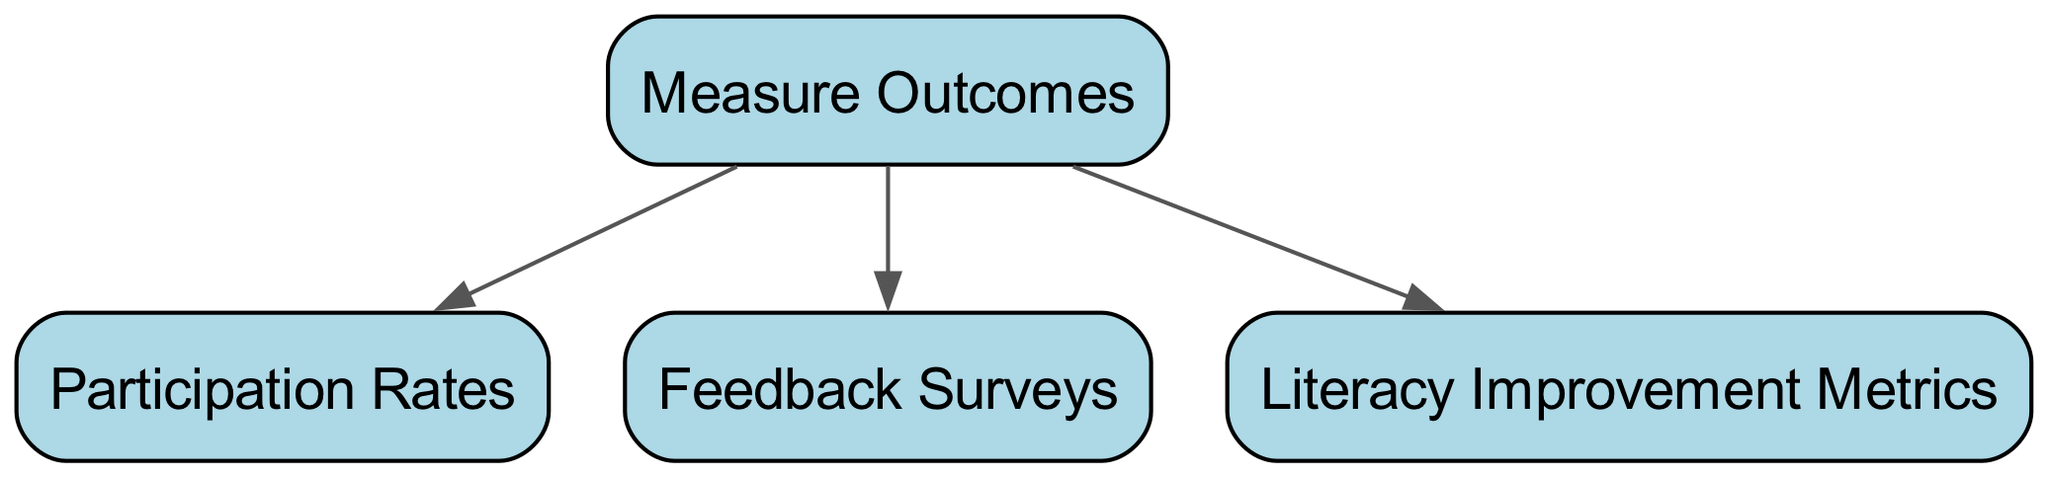What are the main goals outlined in the decision tree? The tree specifies two main goals: "Enhance Literacy Rates" and "Promote Local Authors." These goals represent the major objectives of the collaboration with local libraries.
Answer: Enhance Literacy Rates, Promote Local Authors How many children does the "Evaluate Resources Needed" node have? The "Evaluate Resources Needed" node has two children: "Staffing Support" and "Financial Resources." Each of these represents a category of resources needed for the events.
Answer: 2 What is one way to enhance literacy rates according to the decision tree? One approach to enhance literacy rates is to "Target Low-Performing Schools." This strategy focuses on specific educational institutions that may require additional support.
Answer: Target Low-Performing Schools Which node is a child of "Promote Local Authors"? The nodes that are children of "Promote Local Authors" are "Host Author Reading Events" and "Provide Signed Book Copies." These events are designed to support and highlight local authors.
Answer: Host Author Reading Events, Provide Signed Book Copies What are the three target audiences identified in the tree? The tree identifies three target audiences: "Children," "Young Adults," and "Adult Learners." These groups represent the demographics targeted for literacy events.
Answer: Children, Young Adults, Adult Learners What resources are needed for staffing support? The resources needed for staffing support include "Library Volunteers" and "Event Coordinators." These individuals are essential for organizing and executing the events.
Answer: Library Volunteers, Event Coordinators What metrics are suggested to measure outcomes? To measure outcomes, the diagram suggests using "Participation Rates," "Feedback Surveys," and "Literacy Improvement Metrics." These metrics provide insight into the effectiveness of the events.
Answer: Participation Rates, Feedback Surveys, Literacy Improvement Metrics How many main decision points are in the diagram? There are four main decision points in the diagram: "Identify Partnership Goals," "Evaluate Resources Needed," "Assess Target Audience," and "Measure Outcomes." Each point represents a critical aspect of planning the literacy events.
Answer: 4 What does the diagram suggest is a way to evaluate financial resources? The diagram suggests evaluating financial resources through "Sponsorships" and "Grant Applications." These methods help secure necessary funding for the events.
Answer: Sponsorships, Grant Applications 